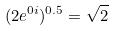<formula> <loc_0><loc_0><loc_500><loc_500>( 2 e ^ { 0 i } ) ^ { 0 . 5 } = \sqrt { 2 }</formula> 